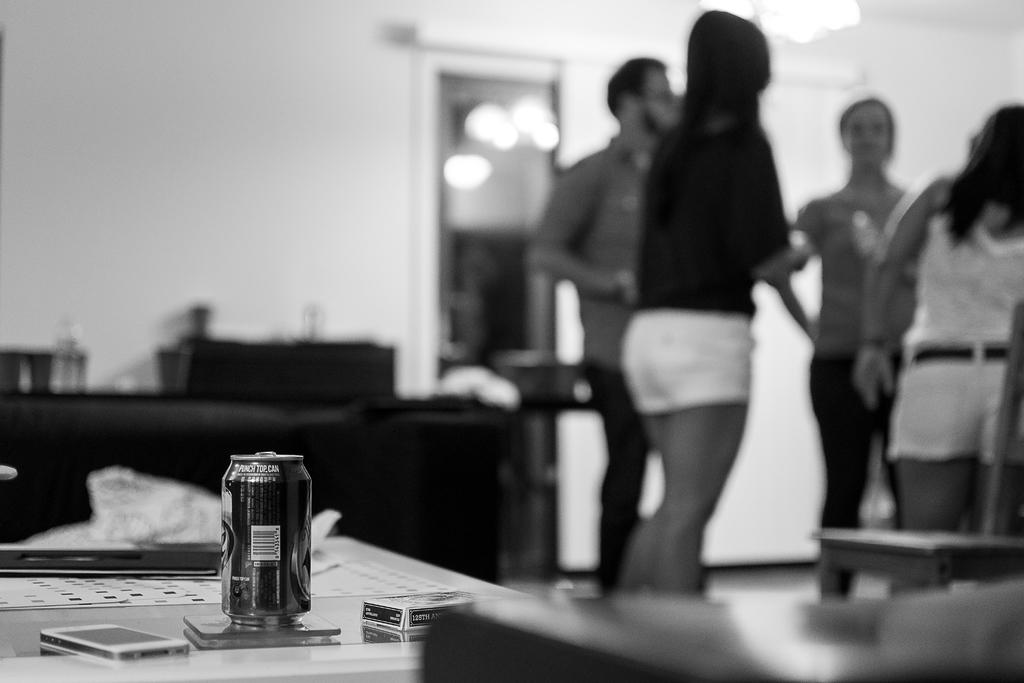How many people are present in the image? There are four people in the image. Where are the people located in the image? The people are standing to the left side. What is on the table in the image? There is a tin and a phone on the table, along with other things. Can you describe the table in the image? The table has a tin, a phone, and other items placed on it. What type of fish can be seen swimming in the tin on the table? There is no fish present in the image, and the tin does not contain any liquid for a fish to swim in. 